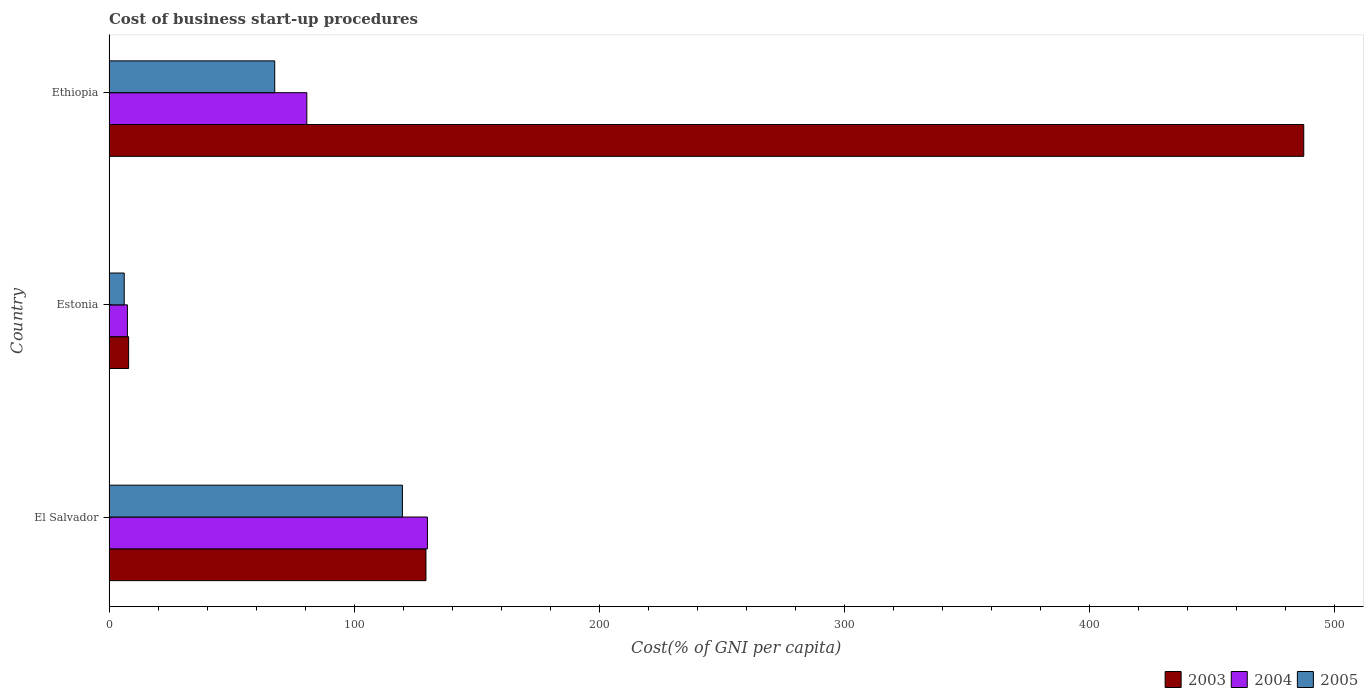Are the number of bars per tick equal to the number of legend labels?
Your answer should be compact. Yes. How many bars are there on the 2nd tick from the top?
Provide a short and direct response. 3. What is the label of the 3rd group of bars from the top?
Give a very brief answer. El Salvador. What is the cost of business start-up procedures in 2004 in El Salvador?
Offer a very short reply. 129.9. Across all countries, what is the maximum cost of business start-up procedures in 2004?
Your response must be concise. 129.9. Across all countries, what is the minimum cost of business start-up procedures in 2005?
Your answer should be compact. 6.2. In which country was the cost of business start-up procedures in 2005 maximum?
Offer a very short reply. El Salvador. In which country was the cost of business start-up procedures in 2003 minimum?
Offer a terse response. Estonia. What is the total cost of business start-up procedures in 2005 in the graph?
Ensure brevity in your answer.  193.5. What is the difference between the cost of business start-up procedures in 2004 in El Salvador and that in Estonia?
Offer a very short reply. 122.4. What is the average cost of business start-up procedures in 2004 per country?
Provide a succinct answer. 72.7. What is the difference between the cost of business start-up procedures in 2004 and cost of business start-up procedures in 2003 in El Salvador?
Offer a very short reply. 0.6. What is the ratio of the cost of business start-up procedures in 2004 in El Salvador to that in Estonia?
Provide a succinct answer. 17.32. What is the difference between the highest and the second highest cost of business start-up procedures in 2004?
Keep it short and to the point. 49.2. What is the difference between the highest and the lowest cost of business start-up procedures in 2004?
Give a very brief answer. 122.4. What does the 1st bar from the top in Ethiopia represents?
Provide a short and direct response. 2005. How many bars are there?
Your answer should be compact. 9. How many countries are there in the graph?
Ensure brevity in your answer.  3. Does the graph contain any zero values?
Offer a very short reply. No. Where does the legend appear in the graph?
Give a very brief answer. Bottom right. What is the title of the graph?
Make the answer very short. Cost of business start-up procedures. What is the label or title of the X-axis?
Your answer should be compact. Cost(% of GNI per capita). What is the label or title of the Y-axis?
Ensure brevity in your answer.  Country. What is the Cost(% of GNI per capita) of 2003 in El Salvador?
Offer a very short reply. 129.3. What is the Cost(% of GNI per capita) in 2004 in El Salvador?
Ensure brevity in your answer.  129.9. What is the Cost(% of GNI per capita) of 2005 in El Salvador?
Offer a very short reply. 119.7. What is the Cost(% of GNI per capita) in 2005 in Estonia?
Your answer should be compact. 6.2. What is the Cost(% of GNI per capita) of 2003 in Ethiopia?
Your response must be concise. 487.4. What is the Cost(% of GNI per capita) in 2004 in Ethiopia?
Provide a short and direct response. 80.7. What is the Cost(% of GNI per capita) of 2005 in Ethiopia?
Give a very brief answer. 67.6. Across all countries, what is the maximum Cost(% of GNI per capita) of 2003?
Give a very brief answer. 487.4. Across all countries, what is the maximum Cost(% of GNI per capita) in 2004?
Your answer should be compact. 129.9. Across all countries, what is the maximum Cost(% of GNI per capita) in 2005?
Ensure brevity in your answer.  119.7. Across all countries, what is the minimum Cost(% of GNI per capita) of 2005?
Your answer should be compact. 6.2. What is the total Cost(% of GNI per capita) of 2003 in the graph?
Provide a succinct answer. 624.7. What is the total Cost(% of GNI per capita) of 2004 in the graph?
Make the answer very short. 218.1. What is the total Cost(% of GNI per capita) of 2005 in the graph?
Offer a very short reply. 193.5. What is the difference between the Cost(% of GNI per capita) of 2003 in El Salvador and that in Estonia?
Your response must be concise. 121.3. What is the difference between the Cost(% of GNI per capita) in 2004 in El Salvador and that in Estonia?
Give a very brief answer. 122.4. What is the difference between the Cost(% of GNI per capita) of 2005 in El Salvador and that in Estonia?
Provide a short and direct response. 113.5. What is the difference between the Cost(% of GNI per capita) in 2003 in El Salvador and that in Ethiopia?
Your response must be concise. -358.1. What is the difference between the Cost(% of GNI per capita) in 2004 in El Salvador and that in Ethiopia?
Your response must be concise. 49.2. What is the difference between the Cost(% of GNI per capita) of 2005 in El Salvador and that in Ethiopia?
Give a very brief answer. 52.1. What is the difference between the Cost(% of GNI per capita) of 2003 in Estonia and that in Ethiopia?
Provide a short and direct response. -479.4. What is the difference between the Cost(% of GNI per capita) of 2004 in Estonia and that in Ethiopia?
Offer a terse response. -73.2. What is the difference between the Cost(% of GNI per capita) in 2005 in Estonia and that in Ethiopia?
Your response must be concise. -61.4. What is the difference between the Cost(% of GNI per capita) of 2003 in El Salvador and the Cost(% of GNI per capita) of 2004 in Estonia?
Give a very brief answer. 121.8. What is the difference between the Cost(% of GNI per capita) of 2003 in El Salvador and the Cost(% of GNI per capita) of 2005 in Estonia?
Your answer should be compact. 123.1. What is the difference between the Cost(% of GNI per capita) in 2004 in El Salvador and the Cost(% of GNI per capita) in 2005 in Estonia?
Provide a succinct answer. 123.7. What is the difference between the Cost(% of GNI per capita) in 2003 in El Salvador and the Cost(% of GNI per capita) in 2004 in Ethiopia?
Keep it short and to the point. 48.6. What is the difference between the Cost(% of GNI per capita) of 2003 in El Salvador and the Cost(% of GNI per capita) of 2005 in Ethiopia?
Make the answer very short. 61.7. What is the difference between the Cost(% of GNI per capita) in 2004 in El Salvador and the Cost(% of GNI per capita) in 2005 in Ethiopia?
Keep it short and to the point. 62.3. What is the difference between the Cost(% of GNI per capita) of 2003 in Estonia and the Cost(% of GNI per capita) of 2004 in Ethiopia?
Keep it short and to the point. -72.7. What is the difference between the Cost(% of GNI per capita) in 2003 in Estonia and the Cost(% of GNI per capita) in 2005 in Ethiopia?
Make the answer very short. -59.6. What is the difference between the Cost(% of GNI per capita) of 2004 in Estonia and the Cost(% of GNI per capita) of 2005 in Ethiopia?
Give a very brief answer. -60.1. What is the average Cost(% of GNI per capita) of 2003 per country?
Your response must be concise. 208.23. What is the average Cost(% of GNI per capita) of 2004 per country?
Make the answer very short. 72.7. What is the average Cost(% of GNI per capita) in 2005 per country?
Ensure brevity in your answer.  64.5. What is the difference between the Cost(% of GNI per capita) in 2003 and Cost(% of GNI per capita) in 2005 in El Salvador?
Keep it short and to the point. 9.6. What is the difference between the Cost(% of GNI per capita) in 2004 and Cost(% of GNI per capita) in 2005 in El Salvador?
Make the answer very short. 10.2. What is the difference between the Cost(% of GNI per capita) in 2003 and Cost(% of GNI per capita) in 2004 in Estonia?
Your response must be concise. 0.5. What is the difference between the Cost(% of GNI per capita) in 2003 and Cost(% of GNI per capita) in 2005 in Estonia?
Your answer should be compact. 1.8. What is the difference between the Cost(% of GNI per capita) of 2004 and Cost(% of GNI per capita) of 2005 in Estonia?
Provide a short and direct response. 1.3. What is the difference between the Cost(% of GNI per capita) of 2003 and Cost(% of GNI per capita) of 2004 in Ethiopia?
Your answer should be very brief. 406.7. What is the difference between the Cost(% of GNI per capita) of 2003 and Cost(% of GNI per capita) of 2005 in Ethiopia?
Ensure brevity in your answer.  419.8. What is the difference between the Cost(% of GNI per capita) in 2004 and Cost(% of GNI per capita) in 2005 in Ethiopia?
Ensure brevity in your answer.  13.1. What is the ratio of the Cost(% of GNI per capita) in 2003 in El Salvador to that in Estonia?
Offer a very short reply. 16.16. What is the ratio of the Cost(% of GNI per capita) in 2004 in El Salvador to that in Estonia?
Keep it short and to the point. 17.32. What is the ratio of the Cost(% of GNI per capita) of 2005 in El Salvador to that in Estonia?
Your response must be concise. 19.31. What is the ratio of the Cost(% of GNI per capita) of 2003 in El Salvador to that in Ethiopia?
Your answer should be compact. 0.27. What is the ratio of the Cost(% of GNI per capita) of 2004 in El Salvador to that in Ethiopia?
Your response must be concise. 1.61. What is the ratio of the Cost(% of GNI per capita) of 2005 in El Salvador to that in Ethiopia?
Provide a short and direct response. 1.77. What is the ratio of the Cost(% of GNI per capita) in 2003 in Estonia to that in Ethiopia?
Your answer should be compact. 0.02. What is the ratio of the Cost(% of GNI per capita) in 2004 in Estonia to that in Ethiopia?
Provide a succinct answer. 0.09. What is the ratio of the Cost(% of GNI per capita) of 2005 in Estonia to that in Ethiopia?
Ensure brevity in your answer.  0.09. What is the difference between the highest and the second highest Cost(% of GNI per capita) in 2003?
Make the answer very short. 358.1. What is the difference between the highest and the second highest Cost(% of GNI per capita) of 2004?
Your response must be concise. 49.2. What is the difference between the highest and the second highest Cost(% of GNI per capita) of 2005?
Offer a terse response. 52.1. What is the difference between the highest and the lowest Cost(% of GNI per capita) in 2003?
Make the answer very short. 479.4. What is the difference between the highest and the lowest Cost(% of GNI per capita) of 2004?
Your answer should be compact. 122.4. What is the difference between the highest and the lowest Cost(% of GNI per capita) of 2005?
Offer a very short reply. 113.5. 